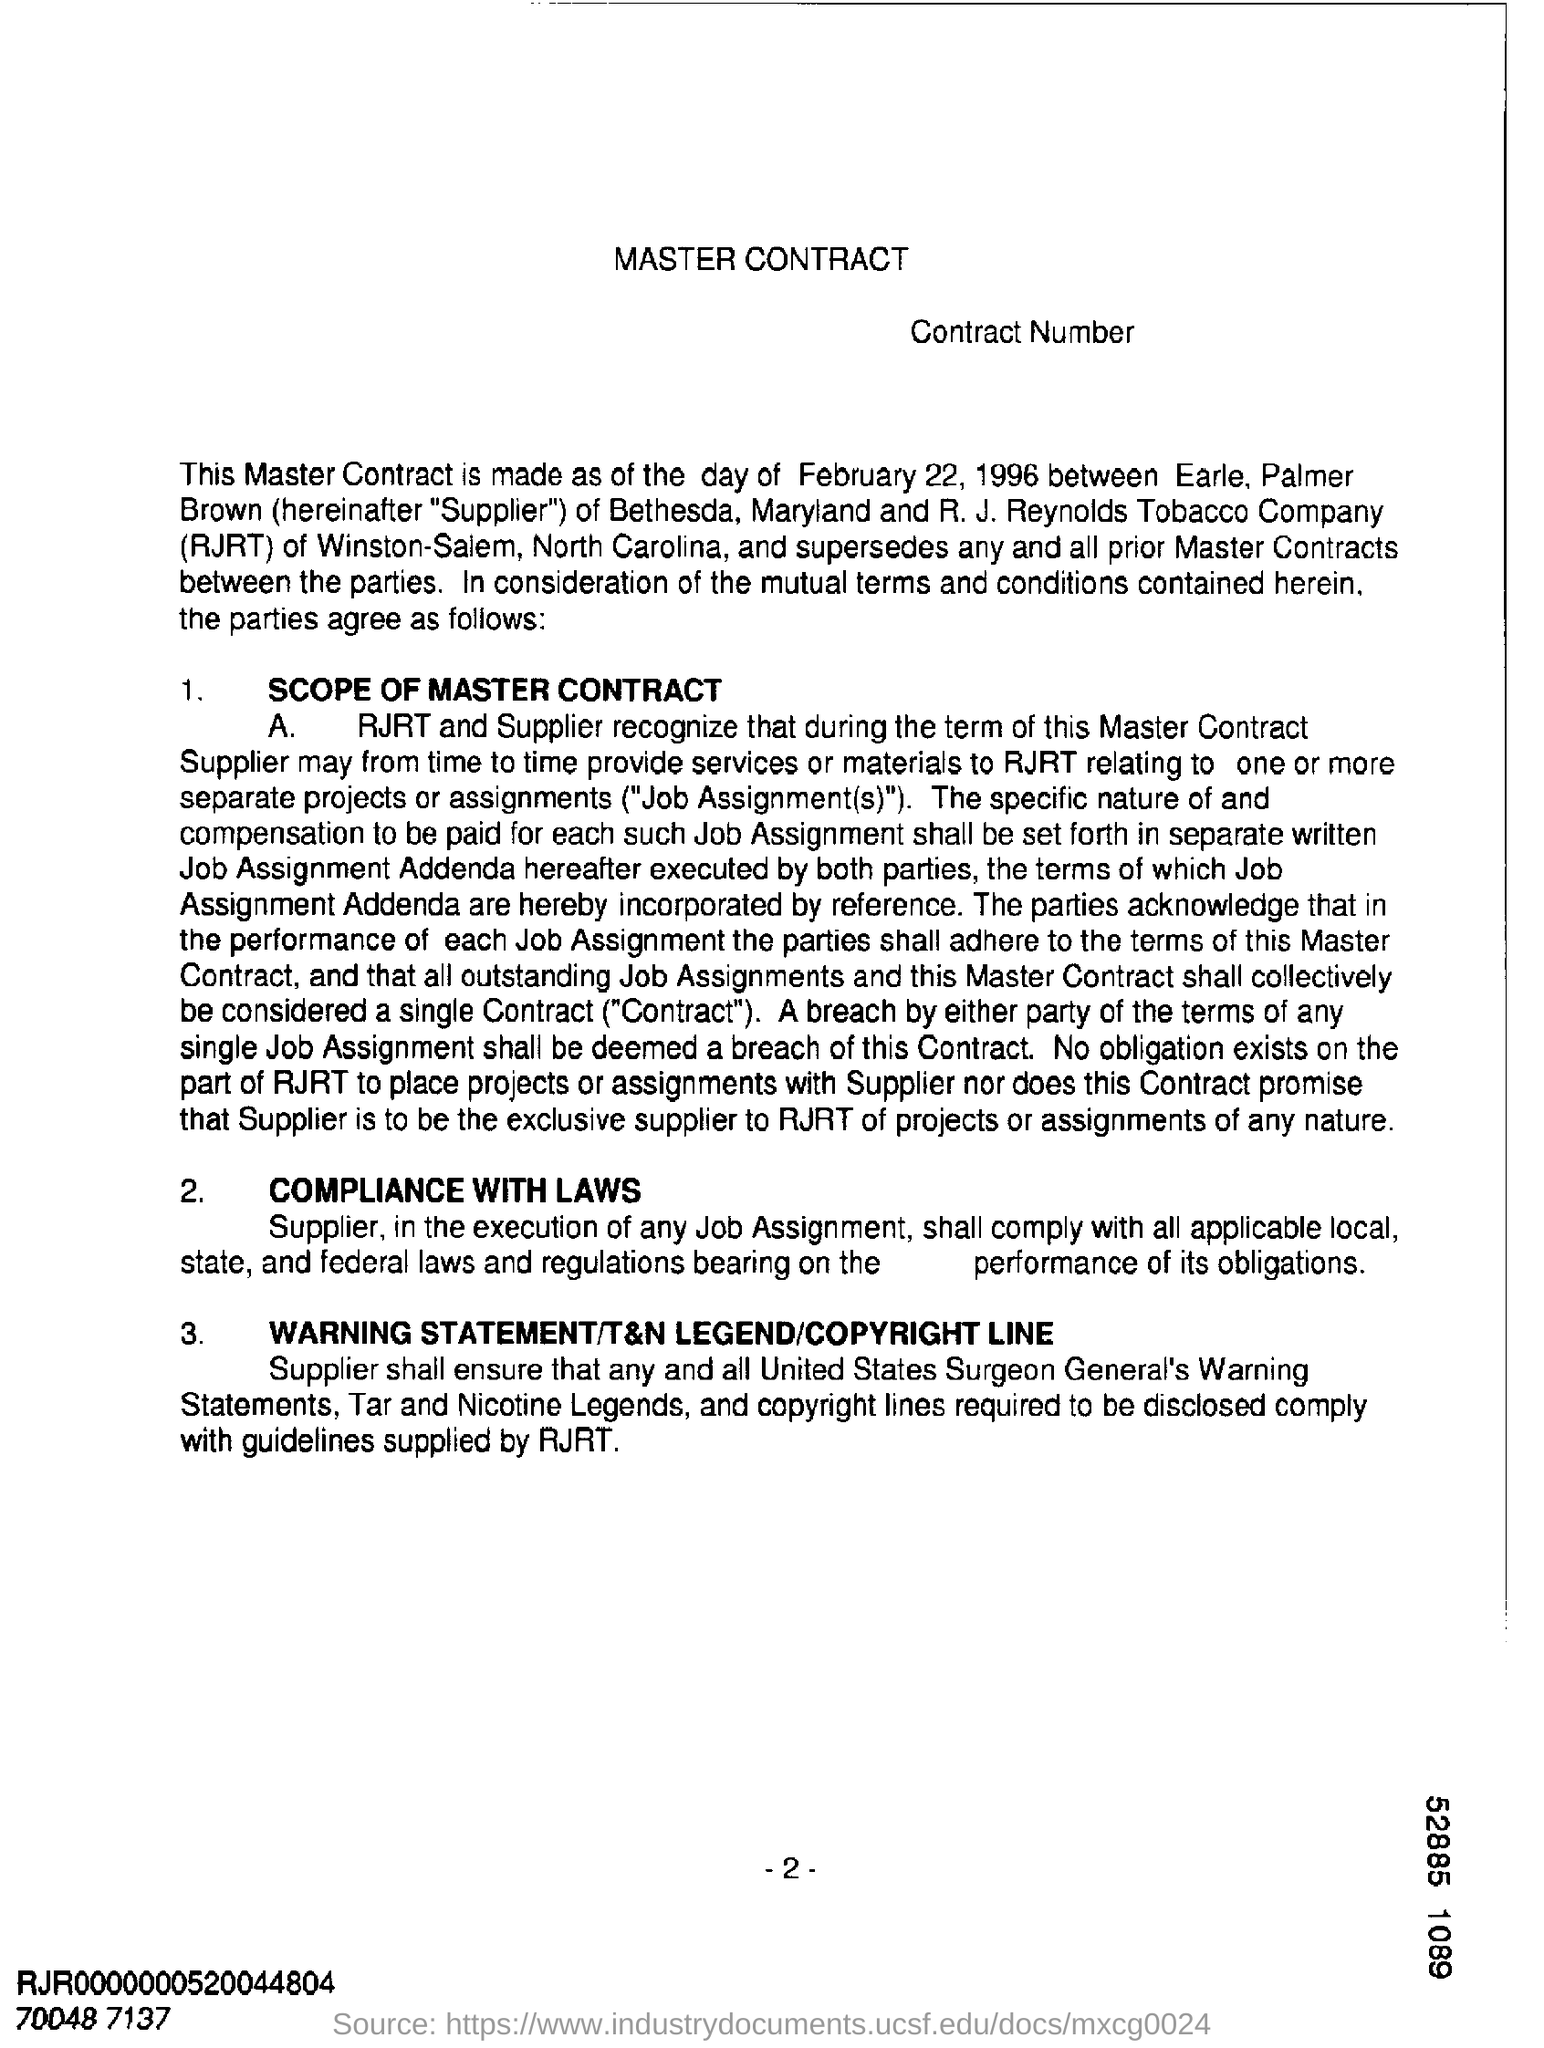Identify some key points in this picture. The agreement was made on February 22, 1996. The heading of the first point is 'SCOPE OF MASTER CONTRACT', which provides a comprehensive overview of the agreement between the parties. The R.J. Reynolds Tobacco Company is mentioned. 